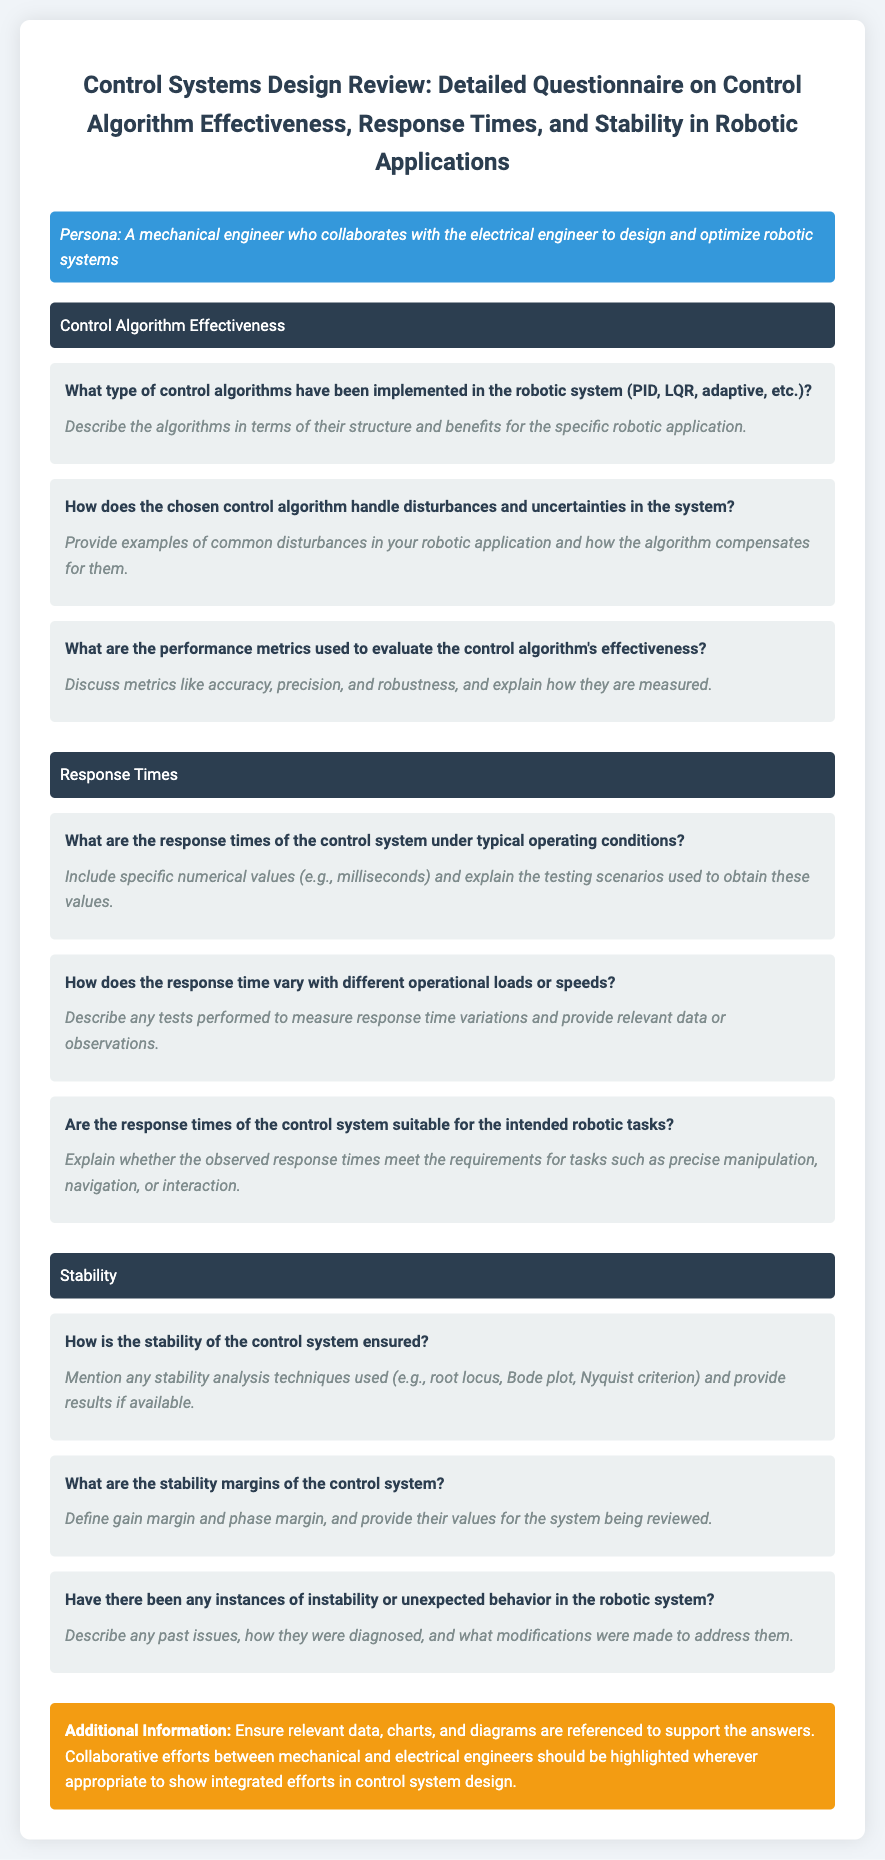What type of control algorithms have been implemented? The document explicitly asks this in the context of the robotic system, requesting types like PID, LQR, and adaptive.
Answer: PID, LQR, adaptive What are the performance metrics used to evaluate the control algorithm's effectiveness? This question refers to the metrics mentioned in the document that assess the control algorithm's performance, including accuracy and precision.
Answer: Accuracy, precision, robustness What are the response times of the control system? The document prompts for specific numerical values under typical conditions for the response times of the control system.
Answer: Specific numerical values What techniques are used to ensure stability in the control system? This question addresses the techniques listed in the document such as root locus, Bode plot, and Nyquist criterion for stability assurance.
Answer: Root locus, Bode plot, Nyquist criterion What are the stability margins of the control system? The document inquires about the definitions and values of gain margin and phase margin relevant to stability.
Answer: Gain margin, phase margin Have there been any instances of instability in the robotic system? This question highlights the document's request for information regarding past instability issues and resolutions.
Answer: Yes/No (specific instances) How does the response time vary with operational loads? The document discusses variations in response time depending on different operational conditions.
Answer: Describe variations observed What additional information should be cited to support the answers? The document suggests including data, charts, and collaborative efforts relevant to control system design.
Answer: Data, charts, diagrams What role do collaborative efforts play in control system design? The document emphasizes the integrated efforts between mechanical and electrical engineers in the design process.
Answer: Highlight integrated efforts 